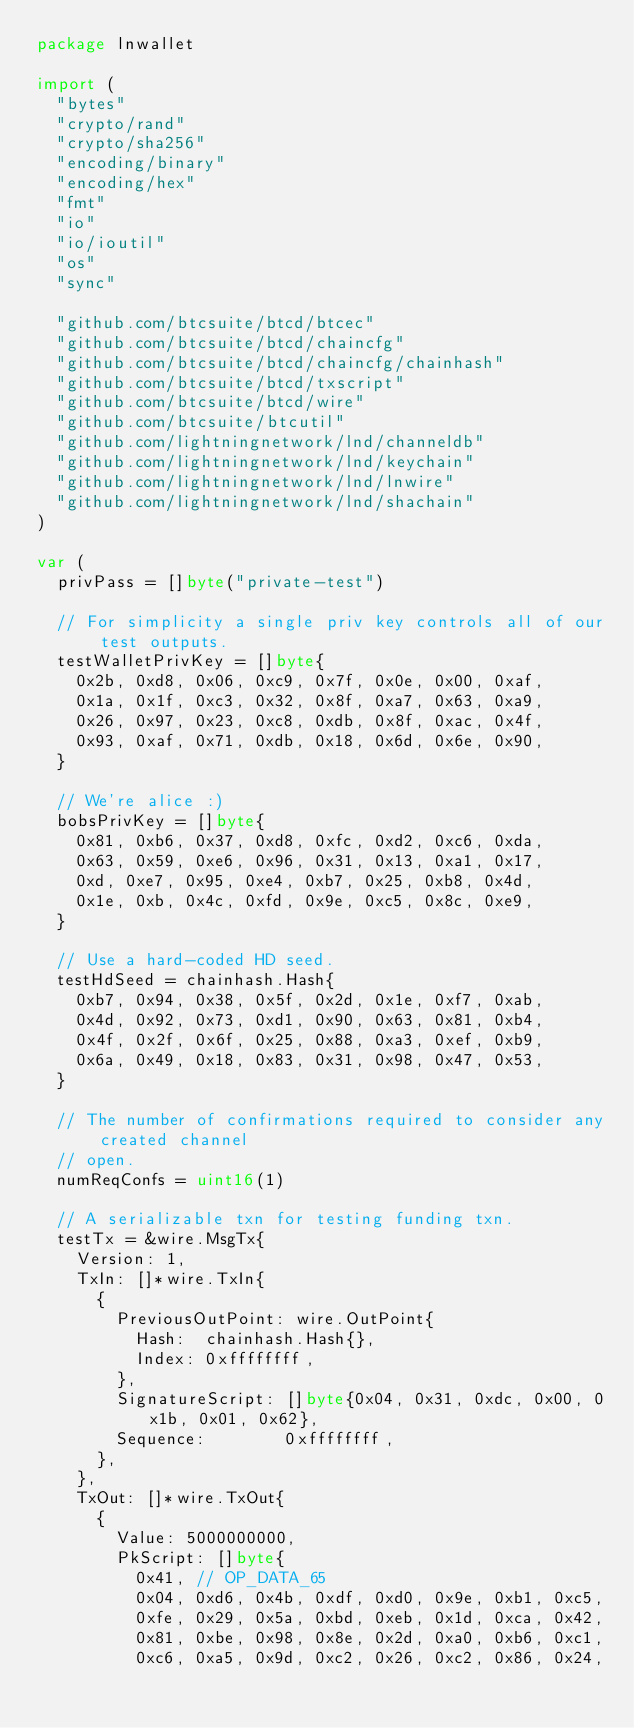<code> <loc_0><loc_0><loc_500><loc_500><_Go_>package lnwallet

import (
	"bytes"
	"crypto/rand"
	"crypto/sha256"
	"encoding/binary"
	"encoding/hex"
	"fmt"
	"io"
	"io/ioutil"
	"os"
	"sync"

	"github.com/btcsuite/btcd/btcec"
	"github.com/btcsuite/btcd/chaincfg"
	"github.com/btcsuite/btcd/chaincfg/chainhash"
	"github.com/btcsuite/btcd/txscript"
	"github.com/btcsuite/btcd/wire"
	"github.com/btcsuite/btcutil"
	"github.com/lightningnetwork/lnd/channeldb"
	"github.com/lightningnetwork/lnd/keychain"
	"github.com/lightningnetwork/lnd/lnwire"
	"github.com/lightningnetwork/lnd/shachain"
)

var (
	privPass = []byte("private-test")

	// For simplicity a single priv key controls all of our test outputs.
	testWalletPrivKey = []byte{
		0x2b, 0xd8, 0x06, 0xc9, 0x7f, 0x0e, 0x00, 0xaf,
		0x1a, 0x1f, 0xc3, 0x32, 0x8f, 0xa7, 0x63, 0xa9,
		0x26, 0x97, 0x23, 0xc8, 0xdb, 0x8f, 0xac, 0x4f,
		0x93, 0xaf, 0x71, 0xdb, 0x18, 0x6d, 0x6e, 0x90,
	}

	// We're alice :)
	bobsPrivKey = []byte{
		0x81, 0xb6, 0x37, 0xd8, 0xfc, 0xd2, 0xc6, 0xda,
		0x63, 0x59, 0xe6, 0x96, 0x31, 0x13, 0xa1, 0x17,
		0xd, 0xe7, 0x95, 0xe4, 0xb7, 0x25, 0xb8, 0x4d,
		0x1e, 0xb, 0x4c, 0xfd, 0x9e, 0xc5, 0x8c, 0xe9,
	}

	// Use a hard-coded HD seed.
	testHdSeed = chainhash.Hash{
		0xb7, 0x94, 0x38, 0x5f, 0x2d, 0x1e, 0xf7, 0xab,
		0x4d, 0x92, 0x73, 0xd1, 0x90, 0x63, 0x81, 0xb4,
		0x4f, 0x2f, 0x6f, 0x25, 0x88, 0xa3, 0xef, 0xb9,
		0x6a, 0x49, 0x18, 0x83, 0x31, 0x98, 0x47, 0x53,
	}

	// The number of confirmations required to consider any created channel
	// open.
	numReqConfs = uint16(1)

	// A serializable txn for testing funding txn.
	testTx = &wire.MsgTx{
		Version: 1,
		TxIn: []*wire.TxIn{
			{
				PreviousOutPoint: wire.OutPoint{
					Hash:  chainhash.Hash{},
					Index: 0xffffffff,
				},
				SignatureScript: []byte{0x04, 0x31, 0xdc, 0x00, 0x1b, 0x01, 0x62},
				Sequence:        0xffffffff,
			},
		},
		TxOut: []*wire.TxOut{
			{
				Value: 5000000000,
				PkScript: []byte{
					0x41, // OP_DATA_65
					0x04, 0xd6, 0x4b, 0xdf, 0xd0, 0x9e, 0xb1, 0xc5,
					0xfe, 0x29, 0x5a, 0xbd, 0xeb, 0x1d, 0xca, 0x42,
					0x81, 0xbe, 0x98, 0x8e, 0x2d, 0xa0, 0xb6, 0xc1,
					0xc6, 0xa5, 0x9d, 0xc2, 0x26, 0xc2, 0x86, 0x24,</code> 